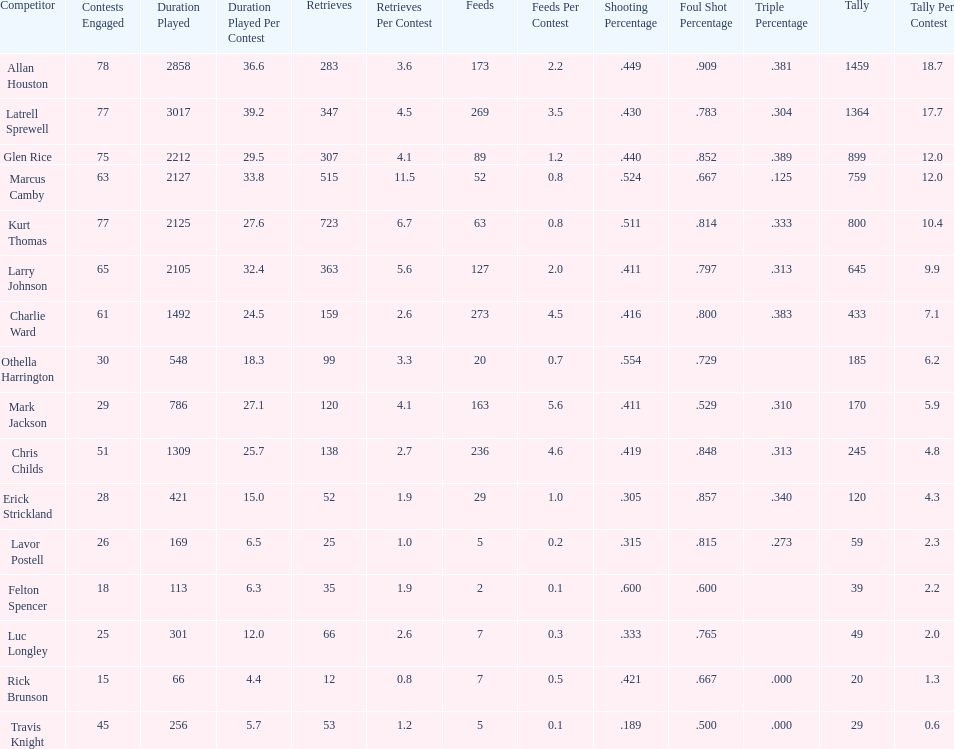Number of players on the team. 16. 